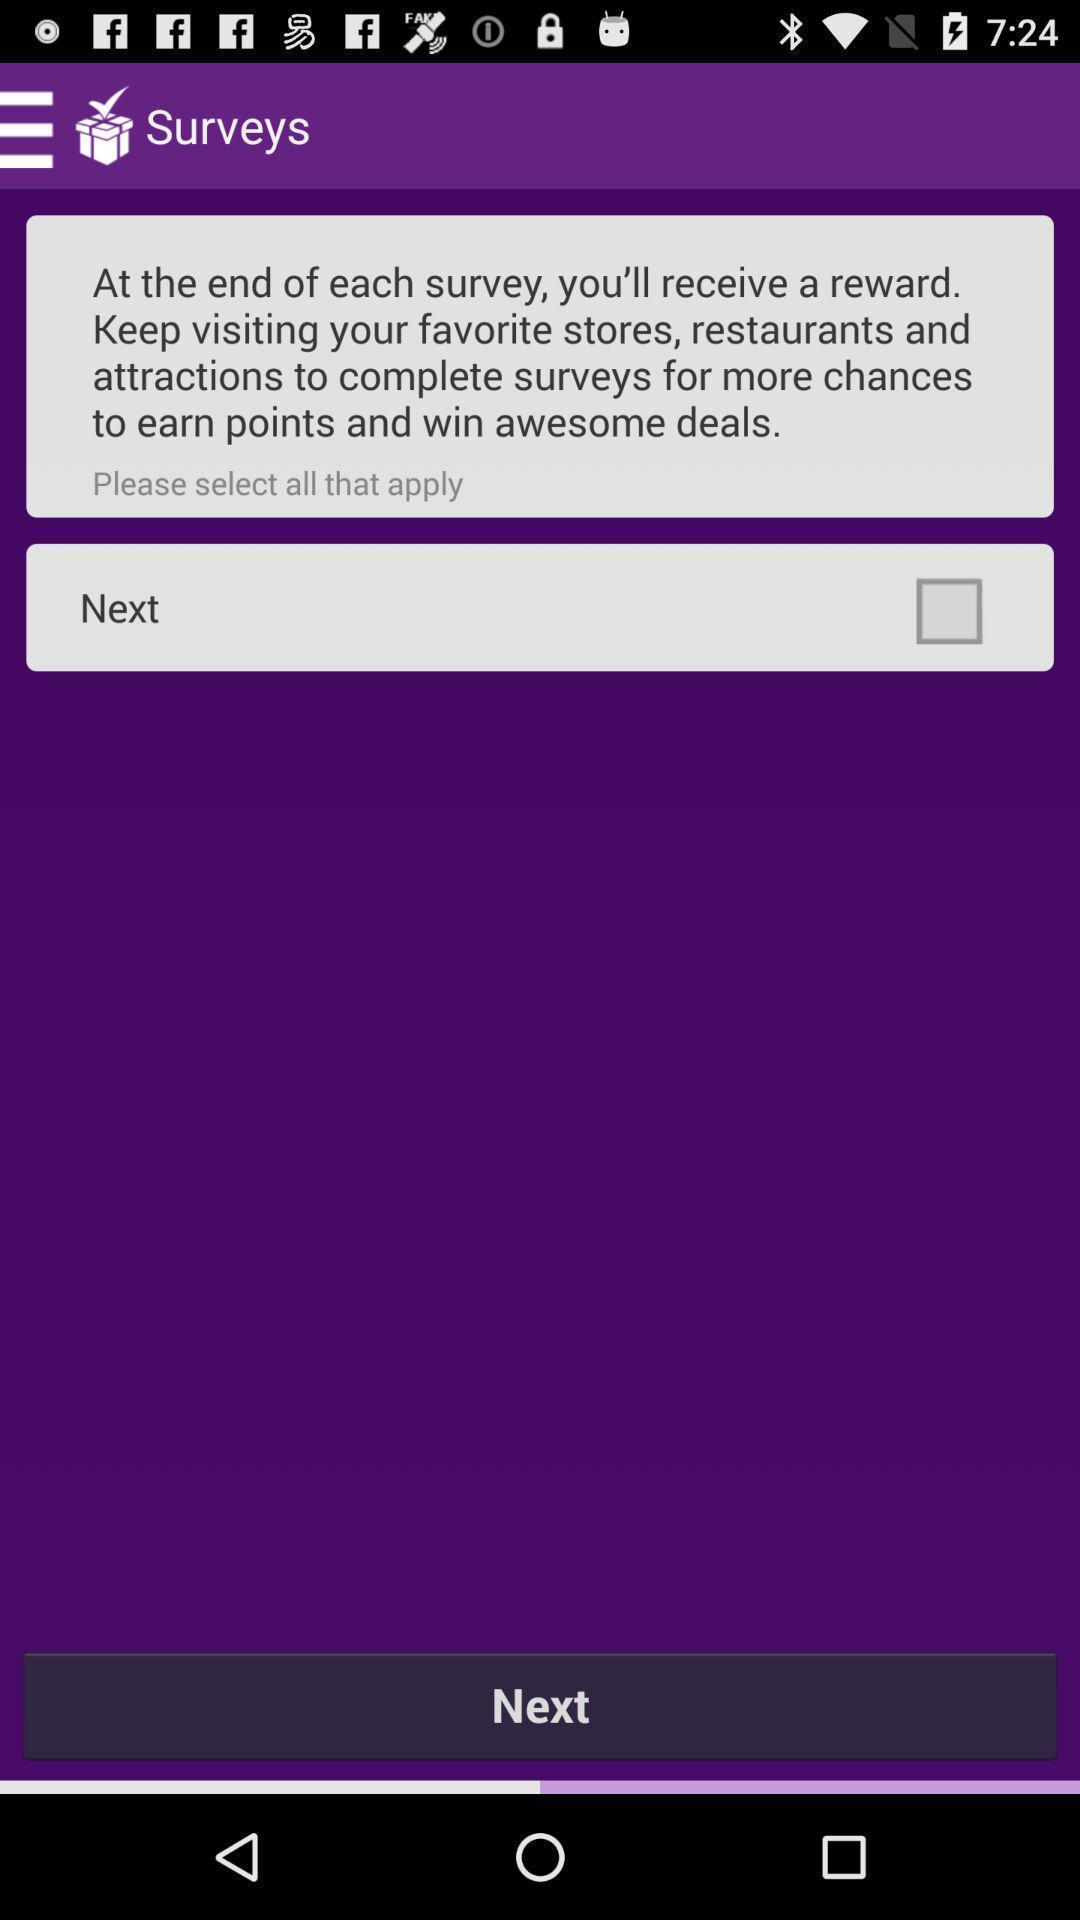Explain the elements present in this screenshot. Survey page. 